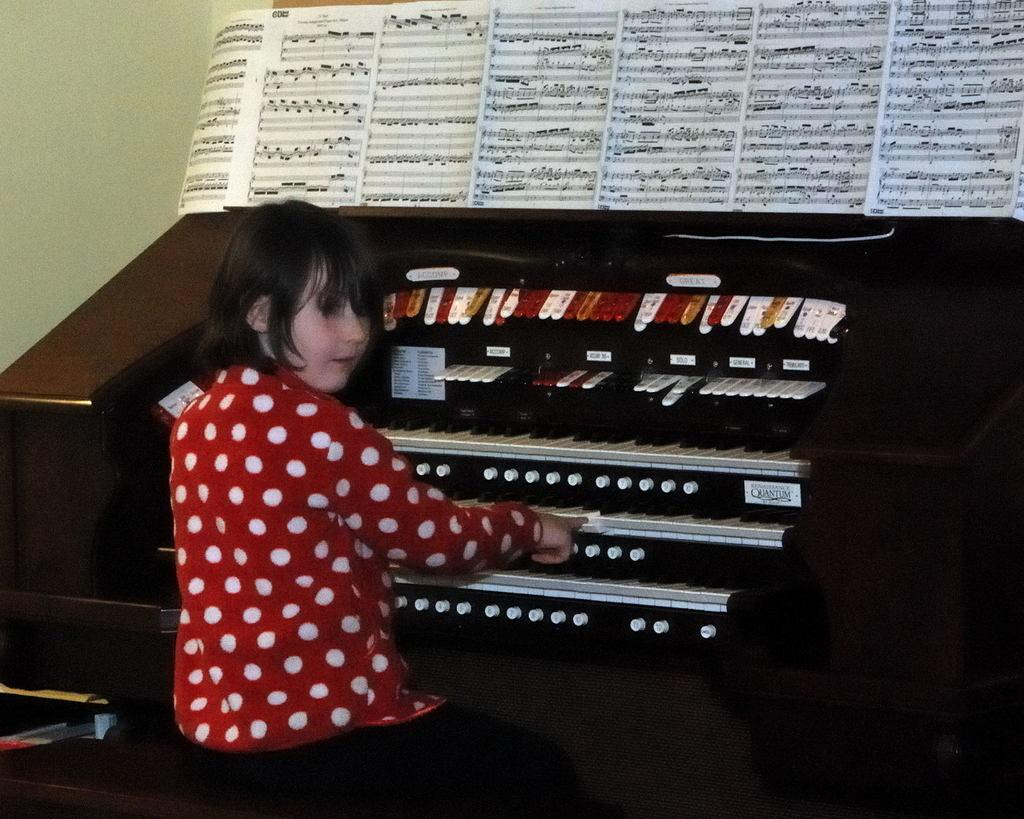Who is the main subject in the image? There is a girl in the image. What is the girl doing in the image? The girl is sitting in front of a piano and playing it. Are there any objects on the piano? Yes, there are books on the piano. What can be seen on the wall in the image? There is a green-colored wall in the image. What type of rock is the girl using to play the piano in the image? There is no rock present in the image; the girl is playing the piano with her hands. What type of pleasure can be seen on the girl's face while playing the piano? The girl's facial expression cannot be determined from the image. 